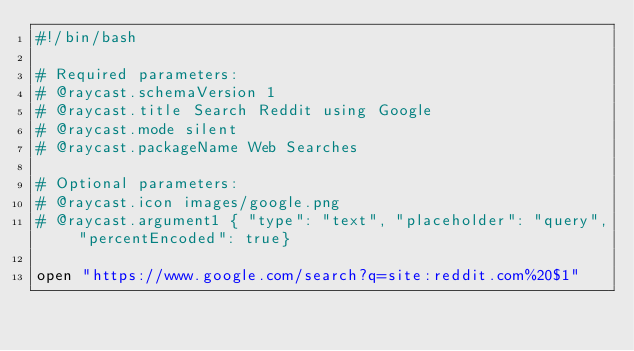Convert code to text. <code><loc_0><loc_0><loc_500><loc_500><_Bash_>#!/bin/bash

# Required parameters:
# @raycast.schemaVersion 1
# @raycast.title Search Reddit using Google
# @raycast.mode silent
# @raycast.packageName Web Searches

# Optional parameters:
# @raycast.icon images/google.png
# @raycast.argument1 { "type": "text", "placeholder": "query", "percentEncoded": true}

open "https://www.google.com/search?q=site:reddit.com%20$1"</code> 